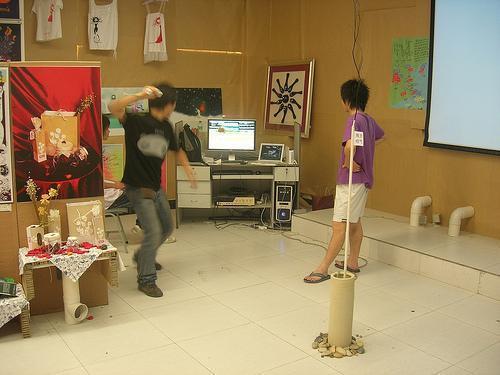How many shirts are hanging above?
Give a very brief answer. 3. How many people are in the picture?
Give a very brief answer. 2. How many people have purple colored shirts in the image?
Give a very brief answer. 1. 